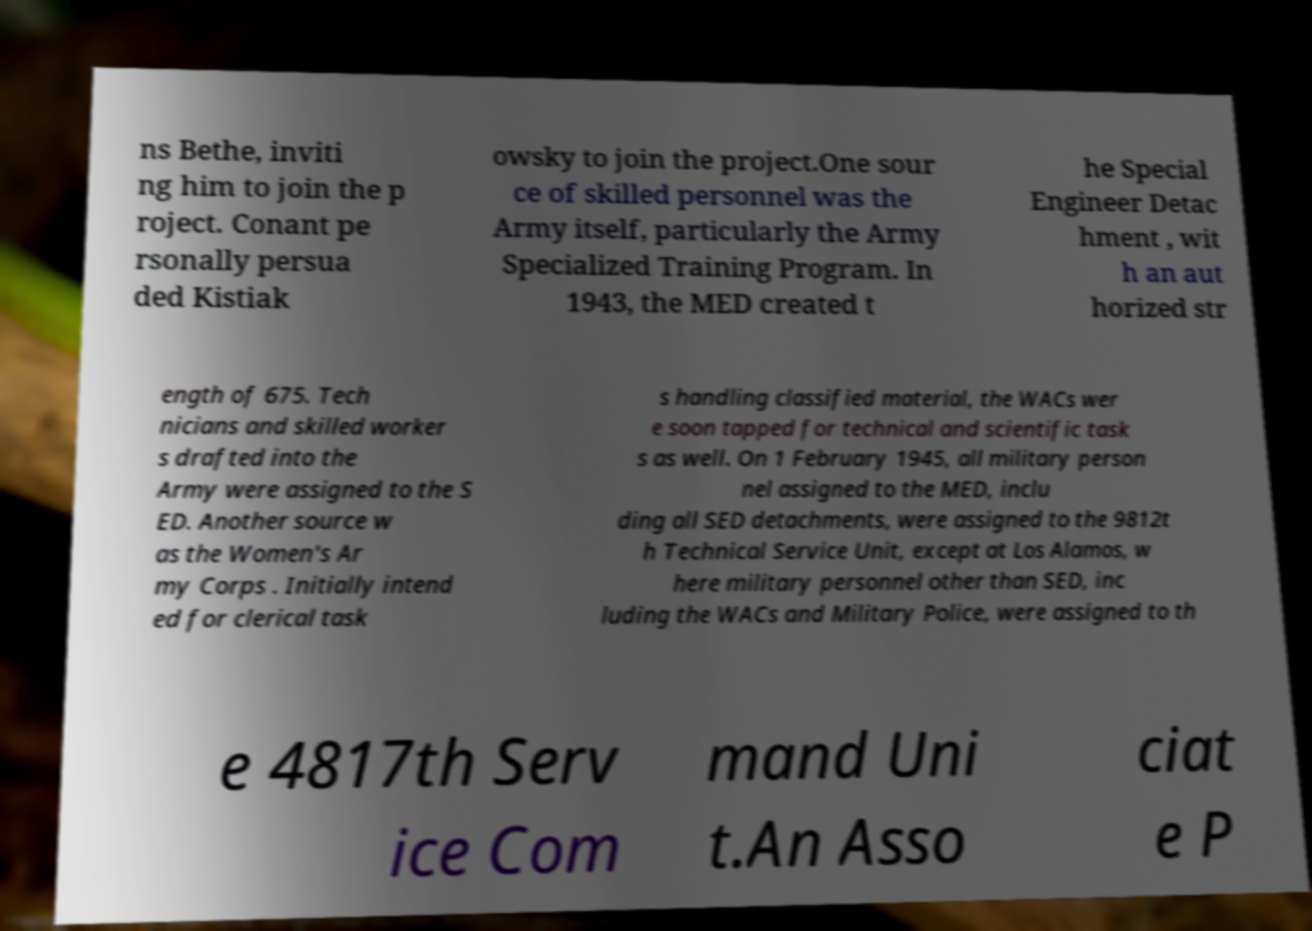Could you assist in decoding the text presented in this image and type it out clearly? ns Bethe, inviti ng him to join the p roject. Conant pe rsonally persua ded Kistiak owsky to join the project.One sour ce of skilled personnel was the Army itself, particularly the Army Specialized Training Program. In 1943, the MED created t he Special Engineer Detac hment , wit h an aut horized str ength of 675. Tech nicians and skilled worker s drafted into the Army were assigned to the S ED. Another source w as the Women's Ar my Corps . Initially intend ed for clerical task s handling classified material, the WACs wer e soon tapped for technical and scientific task s as well. On 1 February 1945, all military person nel assigned to the MED, inclu ding all SED detachments, were assigned to the 9812t h Technical Service Unit, except at Los Alamos, w here military personnel other than SED, inc luding the WACs and Military Police, were assigned to th e 4817th Serv ice Com mand Uni t.An Asso ciat e P 